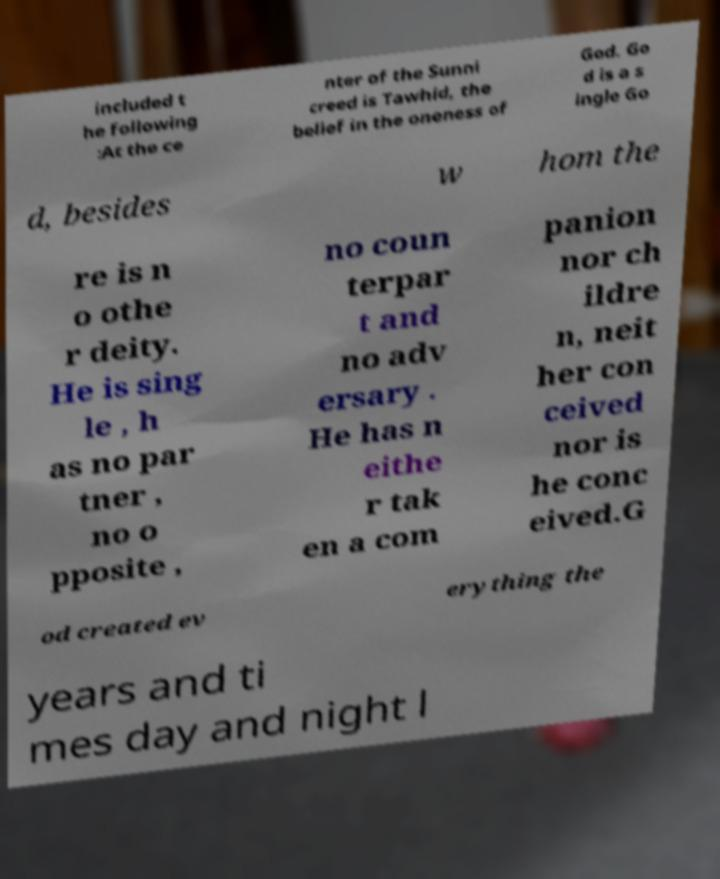I need the written content from this picture converted into text. Can you do that? included t he following :At the ce nter of the Sunni creed is Tawhid, the belief in the oneness of God. Go d is a s ingle Go d, besides w hom the re is n o othe r deity. He is sing le , h as no par tner , no o pposite , no coun terpar t and no adv ersary . He has n eithe r tak en a com panion nor ch ildre n, neit her con ceived nor is he conc eived.G od created ev erything the years and ti mes day and night l 